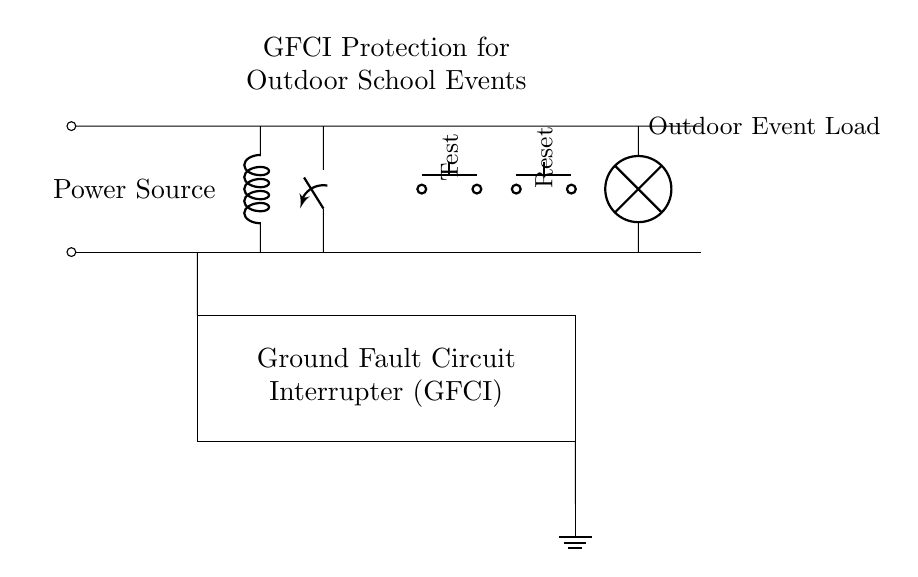What is the main component providing protection in this circuit? The Ground Fault Circuit Interrupter (GFCI) is highlighted in the circuit, indicating it is the main protective component that interrupts the circuit in case of a ground fault.
Answer: Ground Fault Circuit Interrupter What happens when the test button is pressed? Pressing the test button simulates a fault condition, causing the GFCI to trip and disconnect power, confirming its functionality.
Answer: It trips the GFCI What is the purpose of the reset button? The reset button is used to restore power after the GFCI has tripped, allowing normal operation to resume following a fault test or condition.
Answer: Restore power How many push buttons are present in the circuit? The diagram shows two push buttons, one for testing and one for resetting, which are clearly labeled.
Answer: Two What type of load is connected to the circuit? The load connected to the circuit is identified as an "Outdoor Event Load," indicating its purpose is likely related to an event held outside.
Answer: Outdoor Event Load How does the sensing coil function in the circuit? The sensing coil detects imbalances in the current flow between the live and neutral wires, enabling the GFCI to act quickly if a ground fault occurs, ensuring user safety.
Answer: Detects current imbalances What is the significance of the ground connection in this circuit? The ground connection serves as a safety mechanism to direct excess current safely into the ground, preventing electric shock and equipment damage during a fault condition.
Answer: Safety mechanism 